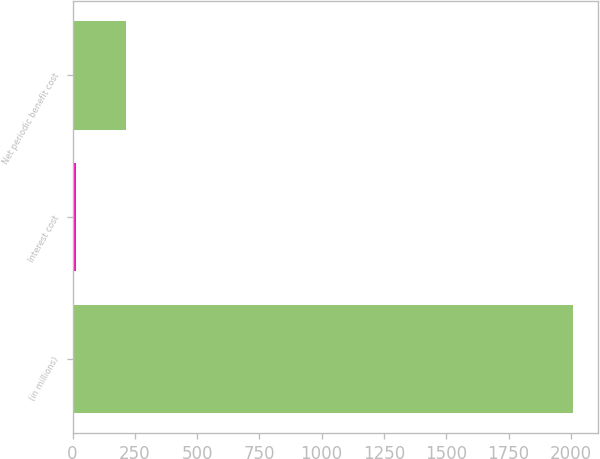Convert chart. <chart><loc_0><loc_0><loc_500><loc_500><bar_chart><fcel>(in millions)<fcel>Interest cost<fcel>Net periodic benefit cost<nl><fcel>2007<fcel>15<fcel>214.2<nl></chart> 